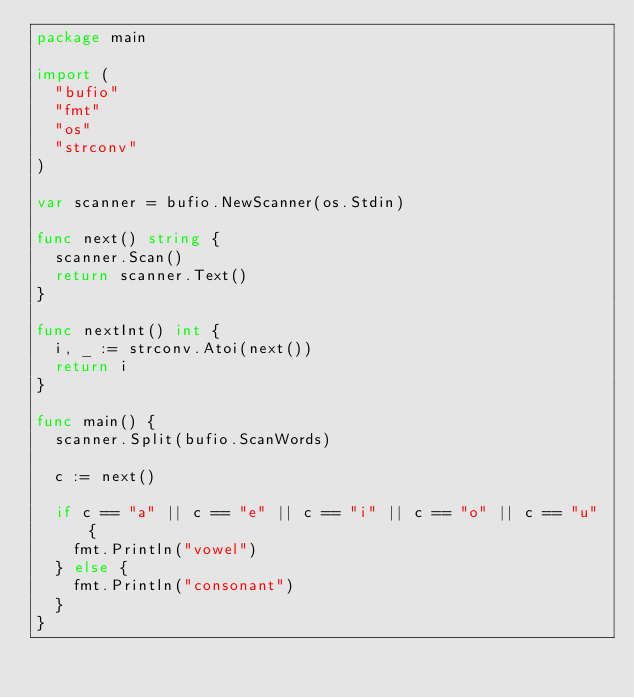<code> <loc_0><loc_0><loc_500><loc_500><_Go_>package main

import (
	"bufio"
	"fmt"
	"os"
	"strconv"
)

var scanner = bufio.NewScanner(os.Stdin)

func next() string {
	scanner.Scan()
	return scanner.Text()
}

func nextInt() int {
	i, _ := strconv.Atoi(next())
	return i
}

func main() {
	scanner.Split(bufio.ScanWords)

	c := next()

	if c == "a" || c == "e" || c == "i" || c == "o" || c == "u" {
		fmt.Println("vowel")
	} else {
		fmt.Println("consonant")
	}
}
</code> 